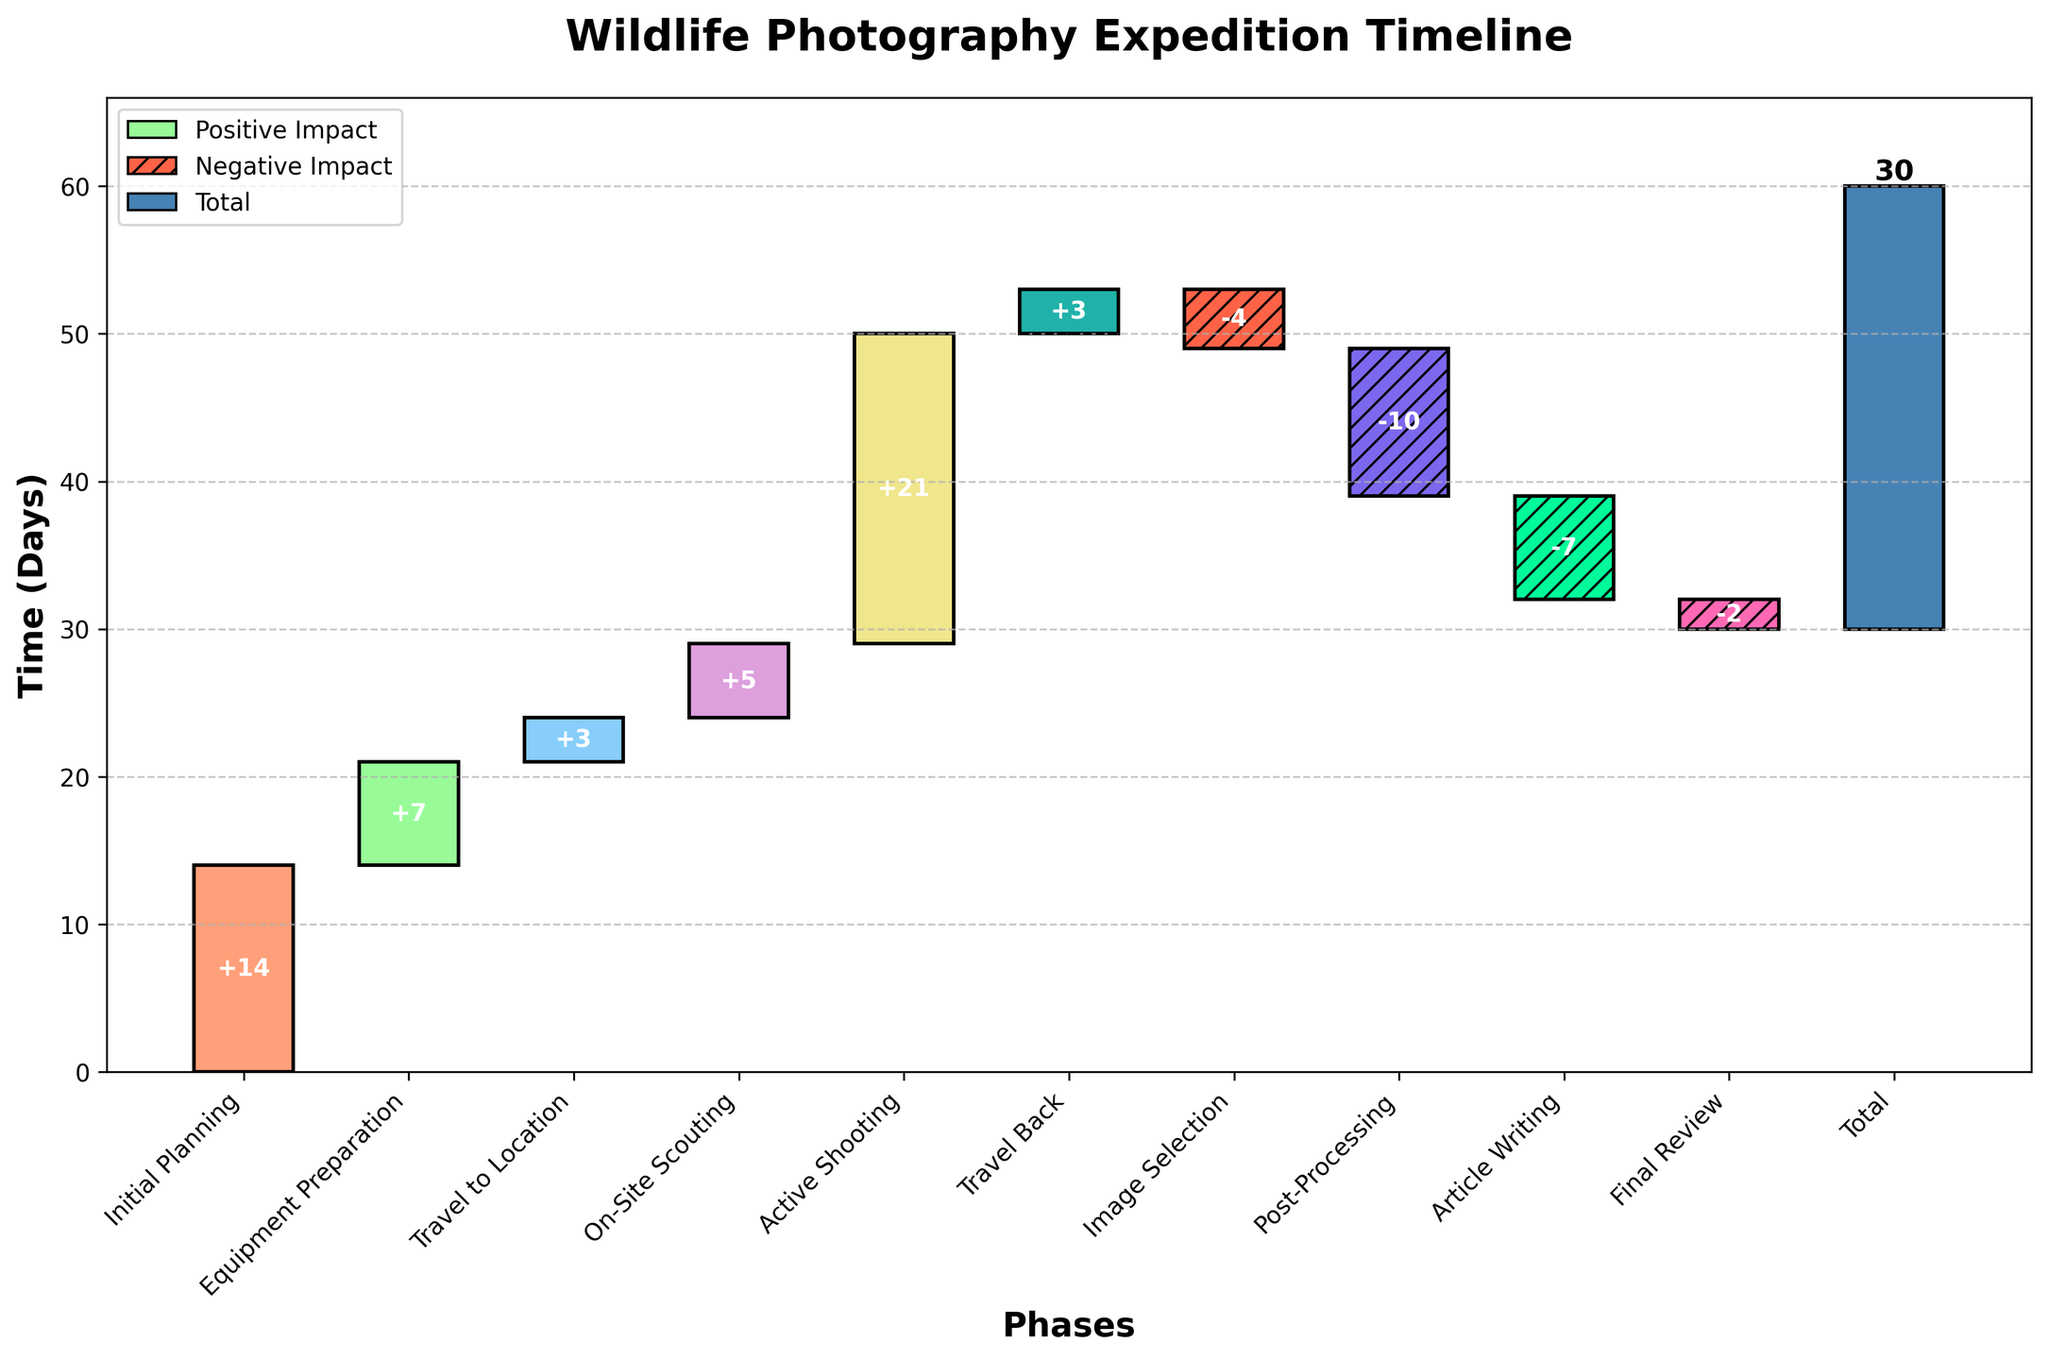What is the title of the chart? The title is usually located at the top of the chart. In this case, it can be seen at the top. It reads "Wildlife Photography Expedition Timeline"
Answer: Wildlife Photography Expedition Timeline Which phase takes the longest time? The phase bars can be compared to determine their length. The "Active Shooting" phase has the longest bar on the chart.
Answer: Active Shooting How many days were spent in "Travel to Location"? The "Travel to Location" phase bar is labeled, and we can see that it represents 3 days.
Answer: 3 What phases had negative time values? Negative time values can be identified by downward bars. The phases with negative values are "Image Selection", "Post-Processing", "Article Writing", and "Final Review".
Answer: Image Selection, Post-Processing, Article Writing, Final Review What is the net effect (in days) of the post-expedition phases? The post-expedition phases are "Image Selection", "Post-Processing", "Article Writing", and "Final Review". Summing their effects: -4 + (-10) + (-7) + (-2) = -23 days
Answer: -23 days How many days were spent in travel (both to and from the location)? Add the days spent in "Travel to Location" and "Travel Back". The days are 3 + 3 = 6 days.
Answer: 6 days Which phase immediately follows "On-Site Scouting"? The phases are labeled in order. The phase immediately following "On-Site Scouting" is "Active Shooting".
Answer: Active Shooting How many phases had positive contributions to the total time spent? Positive contributions appear as upward bars. The phases contributing positively are "Initial Planning", "Equipment Preparation", "Travel to Location", "On-Site Scouting", "Active Shooting", and "Travel Back".
Answer: 6 phases Which phase had the smallest negative impact? By comparing the length of the downward bars, the "Final Review" phase shows the smallest negative impact, with -2 days.
Answer: Final Review What is the cumulative total time spent, as shown in the chart? The cumulative total is shown as the final bar labeled "Total" which represents 30 days.
Answer: 30 days 